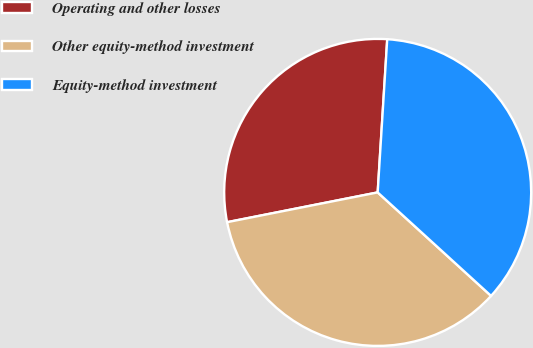<chart> <loc_0><loc_0><loc_500><loc_500><pie_chart><fcel>Operating and other losses<fcel>Other equity-method investment<fcel>Equity-method investment<nl><fcel>29.1%<fcel>35.12%<fcel>35.78%<nl></chart> 